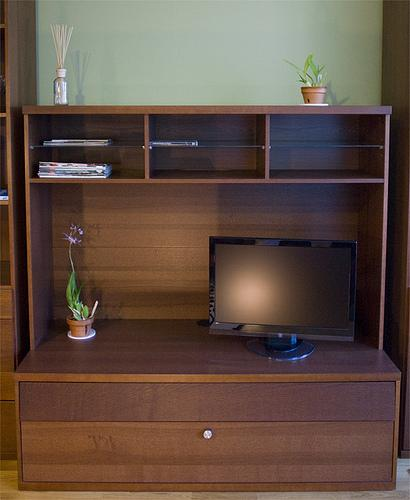Question: how do you open the drawer?
Choices:
A. Pull the knob.
B. Pull the handle.
C. It doesn't open.
D. Press it in and it pops out.
Answer with the letter. Answer: A Question: how many plants are there?
Choices:
A. One.
B. Two.
C. Three.
D. Four.
Answer with the letter. Answer: B Question: what is sticking up out of the jar?
Choices:
A. Reeds.
B. Flowers.
C. Cooking utensils.
D. Straws.
Answer with the letter. Answer: A Question: what is on the top left of the shelf?
Choices:
A. Towels.
B. Air freshener.
C. Toilet paper.
D. Tootbrush.
Answer with the letter. Answer: B Question: what color is the flower?
Choices:
A. Purple.
B. Red.
C. White.
D. Blue.
Answer with the letter. Answer: A Question: what color is the wall?
Choices:
A. Black.
B. White.
C. Beige.
D. Green.
Answer with the letter. Answer: D 